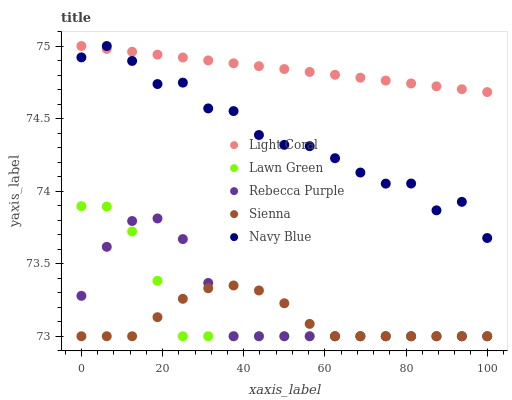Does Sienna have the minimum area under the curve?
Answer yes or no. Yes. Does Light Coral have the maximum area under the curve?
Answer yes or no. Yes. Does Lawn Green have the minimum area under the curve?
Answer yes or no. No. Does Lawn Green have the maximum area under the curve?
Answer yes or no. No. Is Light Coral the smoothest?
Answer yes or no. Yes. Is Navy Blue the roughest?
Answer yes or no. Yes. Is Lawn Green the smoothest?
Answer yes or no. No. Is Lawn Green the roughest?
Answer yes or no. No. Does Lawn Green have the lowest value?
Answer yes or no. Yes. Does Navy Blue have the lowest value?
Answer yes or no. No. Does Navy Blue have the highest value?
Answer yes or no. Yes. Does Lawn Green have the highest value?
Answer yes or no. No. Is Sienna less than Light Coral?
Answer yes or no. Yes. Is Navy Blue greater than Lawn Green?
Answer yes or no. Yes. Does Rebecca Purple intersect Sienna?
Answer yes or no. Yes. Is Rebecca Purple less than Sienna?
Answer yes or no. No. Is Rebecca Purple greater than Sienna?
Answer yes or no. No. Does Sienna intersect Light Coral?
Answer yes or no. No. 